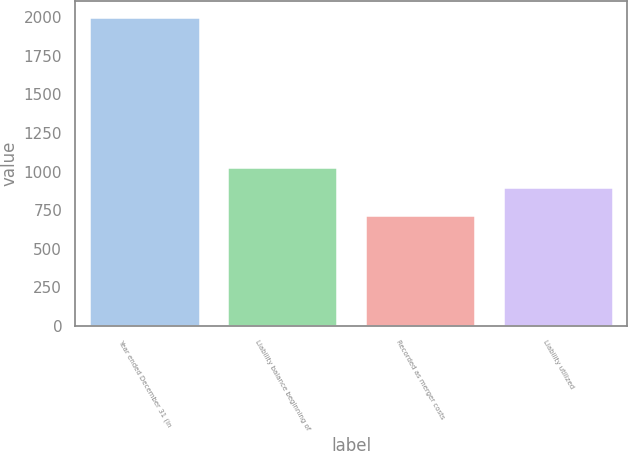Convert chart to OTSL. <chart><loc_0><loc_0><loc_500><loc_500><bar_chart><fcel>Year ended December 31 (in<fcel>Liability balance beginning of<fcel>Recorded as merger costs<fcel>Liability utilized<nl><fcel>2005<fcel>1031.3<fcel>722<fcel>903<nl></chart> 